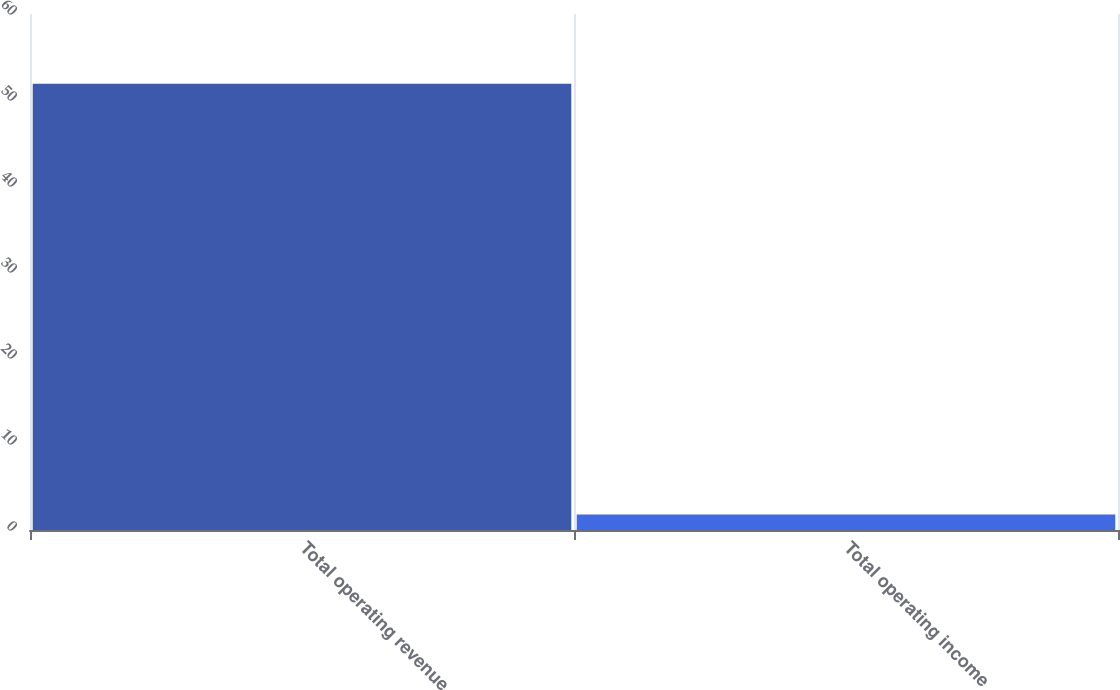<chart> <loc_0><loc_0><loc_500><loc_500><bar_chart><fcel>Total operating revenue<fcel>Total operating income<nl><fcel>51.9<fcel>1.8<nl></chart> 